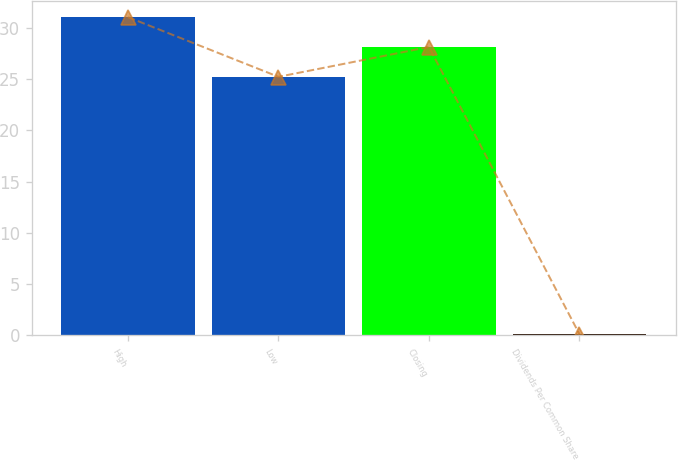<chart> <loc_0><loc_0><loc_500><loc_500><bar_chart><fcel>High<fcel>Low<fcel>Closing<fcel>Dividends Per Common Share<nl><fcel>31.06<fcel>25.24<fcel>28.15<fcel>0.12<nl></chart> 